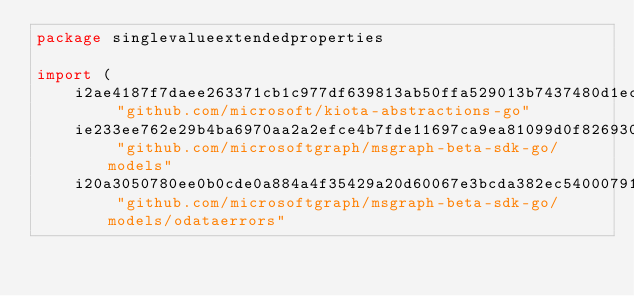Convert code to text. <code><loc_0><loc_0><loc_500><loc_500><_Go_>package singlevalueextendedproperties

import (
    i2ae4187f7daee263371cb1c977df639813ab50ffa529013b7437480d1ec0158f "github.com/microsoft/kiota-abstractions-go"
    ie233ee762e29b4ba6970aa2a2efce4b7fde11697ca9ea81099d0f8269309c1be "github.com/microsoftgraph/msgraph-beta-sdk-go/models"
    i20a3050780ee0b0cde0a884a4f35429a20d60067e3bcda382ec5400079147459 "github.com/microsoftgraph/msgraph-beta-sdk-go/models/odataerrors"</code> 